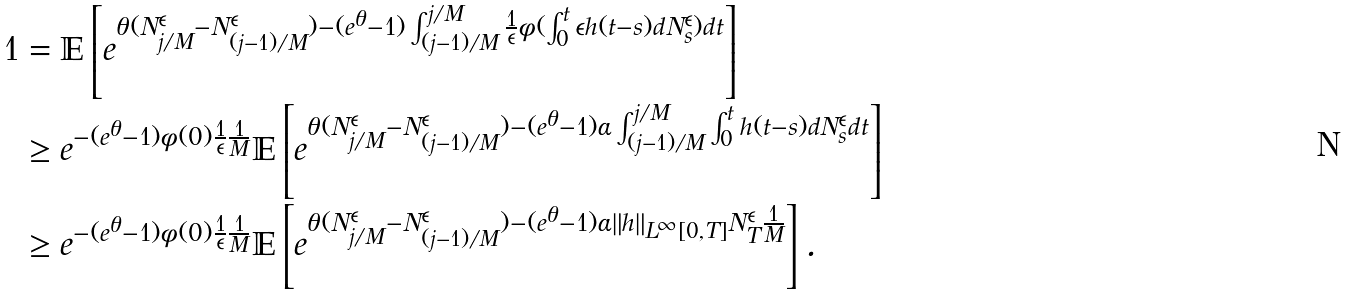<formula> <loc_0><loc_0><loc_500><loc_500>1 & = \mathbb { E } \left [ e ^ { \theta ( N ^ { \epsilon } _ { j / M } - N ^ { \epsilon } _ { ( j - 1 ) / M } ) - ( e ^ { \theta } - 1 ) \int _ { ( j - 1 ) / M } ^ { j / M } \frac { 1 } { \epsilon } \phi ( \int _ { 0 } ^ { t } \epsilon h ( t - s ) d N _ { s } ^ { \epsilon } ) d t } \right ] \\ & \geq e ^ { - ( e ^ { \theta } - 1 ) \phi ( 0 ) \frac { 1 } { \epsilon } \frac { 1 } { M } } \mathbb { E } \left [ e ^ { \theta ( N ^ { \epsilon } _ { j / M } - N ^ { \epsilon } _ { ( j - 1 ) / M } ) - ( e ^ { \theta } - 1 ) \alpha \int _ { ( j - 1 ) / M } ^ { j / M } \int _ { 0 } ^ { t } h ( t - s ) d N _ { s } ^ { \epsilon } d t } \right ] \\ & \geq e ^ { - ( e ^ { \theta } - 1 ) \phi ( 0 ) \frac { 1 } { \epsilon } \frac { 1 } { M } } \mathbb { E } \left [ e ^ { \theta ( N ^ { \epsilon } _ { j / M } - N ^ { \epsilon } _ { ( j - 1 ) / M } ) - ( e ^ { \theta } - 1 ) \alpha \| h \| _ { L ^ { \infty } [ 0 , T ] } N _ { T } ^ { \epsilon } \frac { 1 } { M } } \right ] .</formula> 